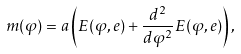Convert formula to latex. <formula><loc_0><loc_0><loc_500><loc_500>m ( \varphi ) = a \left ( E ( \varphi , e ) + { \frac { d ^ { 2 } } { d \varphi ^ { 2 } } } E ( \varphi , e ) \right ) ,</formula> 